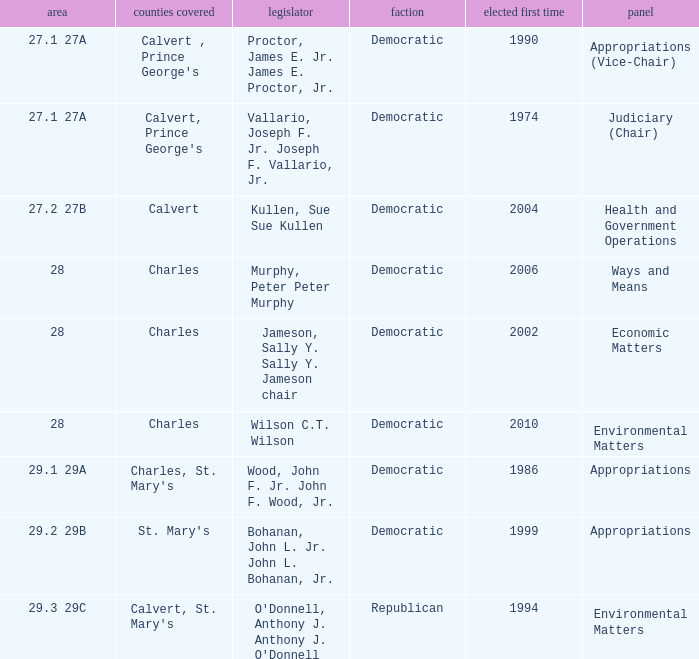When first elected was 2006, who was the delegate? Murphy, Peter Peter Murphy. 